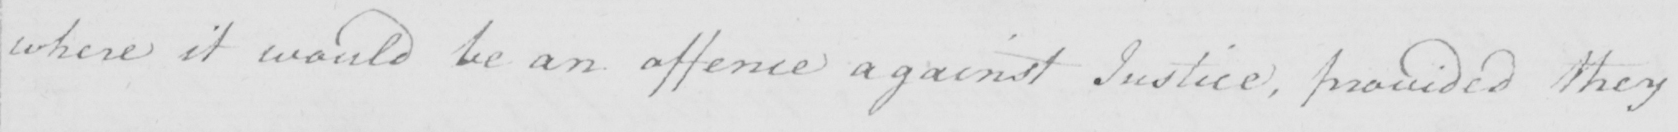Transcribe the text shown in this historical manuscript line. where it would be an offence against Justice , provided they 